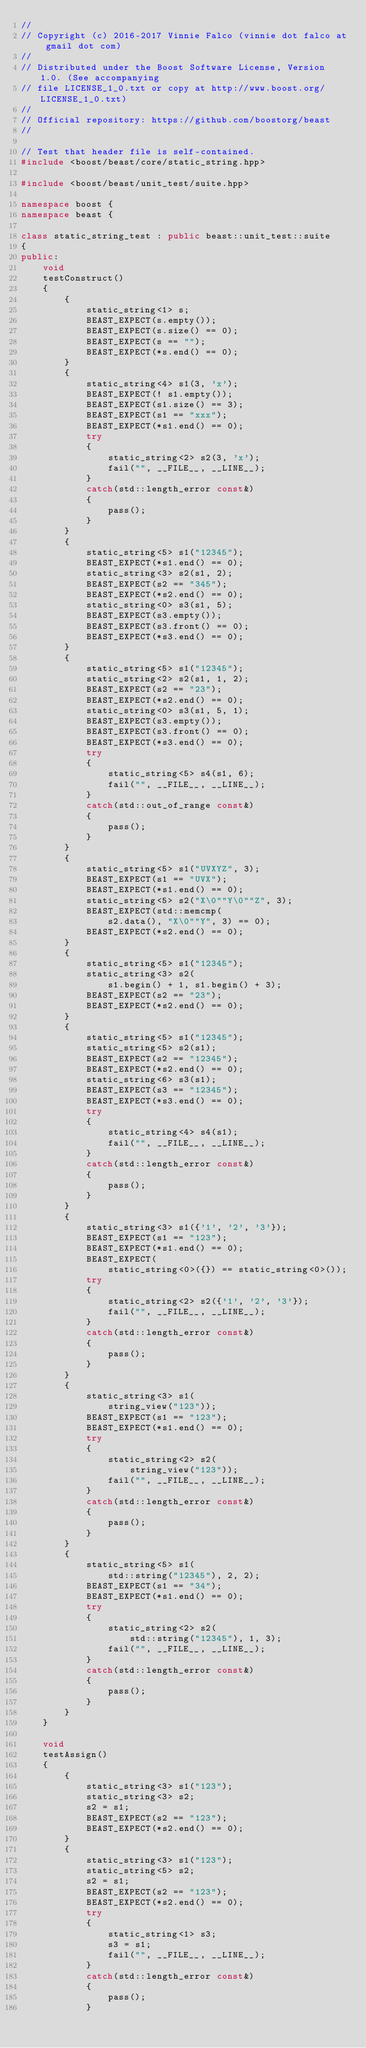Convert code to text. <code><loc_0><loc_0><loc_500><loc_500><_C++_>//
// Copyright (c) 2016-2017 Vinnie Falco (vinnie dot falco at gmail dot com)
//
// Distributed under the Boost Software License, Version 1.0. (See accompanying
// file LICENSE_1_0.txt or copy at http://www.boost.org/LICENSE_1_0.txt)
//
// Official repository: https://github.com/boostorg/beast
//

// Test that header file is self-contained.
#include <boost/beast/core/static_string.hpp>

#include <boost/beast/unit_test/suite.hpp>

namespace boost {
namespace beast {

class static_string_test : public beast::unit_test::suite
{
public:
    void
    testConstruct()
    {
        {
            static_string<1> s;
            BEAST_EXPECT(s.empty());
            BEAST_EXPECT(s.size() == 0);
            BEAST_EXPECT(s == "");
            BEAST_EXPECT(*s.end() == 0);
        }
        {
            static_string<4> s1(3, 'x');
            BEAST_EXPECT(! s1.empty());
            BEAST_EXPECT(s1.size() == 3);
            BEAST_EXPECT(s1 == "xxx");
            BEAST_EXPECT(*s1.end() == 0);
            try
            {
                static_string<2> s2(3, 'x');
                fail("", __FILE__, __LINE__);
            }
            catch(std::length_error const&)
            {
                pass();
            }
        }
        {
            static_string<5> s1("12345");
            BEAST_EXPECT(*s1.end() == 0);
            static_string<3> s2(s1, 2);
            BEAST_EXPECT(s2 == "345");
            BEAST_EXPECT(*s2.end() == 0);
            static_string<0> s3(s1, 5);
            BEAST_EXPECT(s3.empty());
            BEAST_EXPECT(s3.front() == 0);
            BEAST_EXPECT(*s3.end() == 0);
        }
        {
            static_string<5> s1("12345");
            static_string<2> s2(s1, 1, 2);
            BEAST_EXPECT(s2 == "23");
            BEAST_EXPECT(*s2.end() == 0);
            static_string<0> s3(s1, 5, 1);
            BEAST_EXPECT(s3.empty());
            BEAST_EXPECT(s3.front() == 0);
            BEAST_EXPECT(*s3.end() == 0);
            try
            {
                static_string<5> s4(s1, 6);
                fail("", __FILE__, __LINE__);
            }
            catch(std::out_of_range const&)
            {
                pass();
            }
        }
        {
            static_string<5> s1("UVXYZ", 3);
            BEAST_EXPECT(s1 == "UVX");
            BEAST_EXPECT(*s1.end() == 0);
            static_string<5> s2("X\0""Y\0""Z", 3);
            BEAST_EXPECT(std::memcmp(
                s2.data(), "X\0""Y", 3) == 0);
            BEAST_EXPECT(*s2.end() == 0);
        }
        {
            static_string<5> s1("12345");
            static_string<3> s2(
                s1.begin() + 1, s1.begin() + 3);
            BEAST_EXPECT(s2 == "23");
            BEAST_EXPECT(*s2.end() == 0);
        }
        {
            static_string<5> s1("12345");
            static_string<5> s2(s1);
            BEAST_EXPECT(s2 == "12345");
            BEAST_EXPECT(*s2.end() == 0);
            static_string<6> s3(s1);
            BEAST_EXPECT(s3 == "12345");
            BEAST_EXPECT(*s3.end() == 0);
            try
            {
                static_string<4> s4(s1);
                fail("", __FILE__, __LINE__);
            }
            catch(std::length_error const&)
            {
                pass();
            }
        }
        {
            static_string<3> s1({'1', '2', '3'});
            BEAST_EXPECT(s1 == "123");
            BEAST_EXPECT(*s1.end() == 0);
            BEAST_EXPECT(
                static_string<0>({}) == static_string<0>());
            try
            {
                static_string<2> s2({'1', '2', '3'});
                fail("", __FILE__, __LINE__);
            }
            catch(std::length_error const&)
            {
                pass();
            }
        }
        {
            static_string<3> s1(
                string_view("123"));
            BEAST_EXPECT(s1 == "123");
            BEAST_EXPECT(*s1.end() == 0);
            try
            {
                static_string<2> s2(
                    string_view("123"));
                fail("", __FILE__, __LINE__);
            }
            catch(std::length_error const&)
            {
                pass();
            }
        }
        {
            static_string<5> s1(
                std::string("12345"), 2, 2);
            BEAST_EXPECT(s1 == "34");
            BEAST_EXPECT(*s1.end() == 0);
            try
            {
                static_string<2> s2(
                    std::string("12345"), 1, 3);
                fail("", __FILE__, __LINE__);
            }
            catch(std::length_error const&)
            {
                pass();
            }
        }
    }

    void
    testAssign()
    {
        {
            static_string<3> s1("123");
            static_string<3> s2;
            s2 = s1;
            BEAST_EXPECT(s2 == "123");
            BEAST_EXPECT(*s2.end() == 0);
        }
        {
            static_string<3> s1("123");
            static_string<5> s2;
            s2 = s1;
            BEAST_EXPECT(s2 == "123");
            BEAST_EXPECT(*s2.end() == 0);
            try
            {
                static_string<1> s3;
                s3 = s1;
                fail("", __FILE__, __LINE__);
            }
            catch(std::length_error const&)
            {
                pass();
            }</code> 